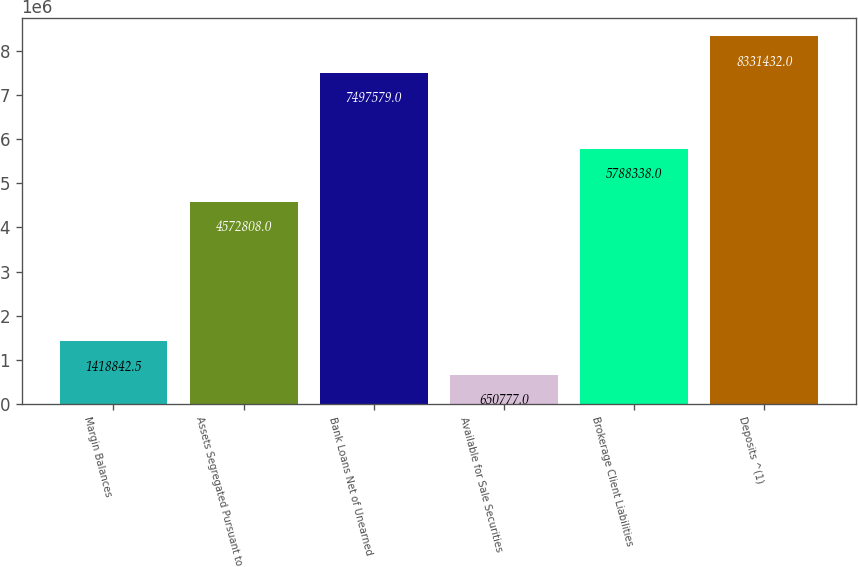Convert chart to OTSL. <chart><loc_0><loc_0><loc_500><loc_500><bar_chart><fcel>Margin Balances<fcel>Assets Segregated Pursuant to<fcel>Bank Loans Net of Unearned<fcel>Available for Sale Securities<fcel>Brokerage Client Liabilities<fcel>Deposits ^(1)<nl><fcel>1.41884e+06<fcel>4.57281e+06<fcel>7.49758e+06<fcel>650777<fcel>5.78834e+06<fcel>8.33143e+06<nl></chart> 